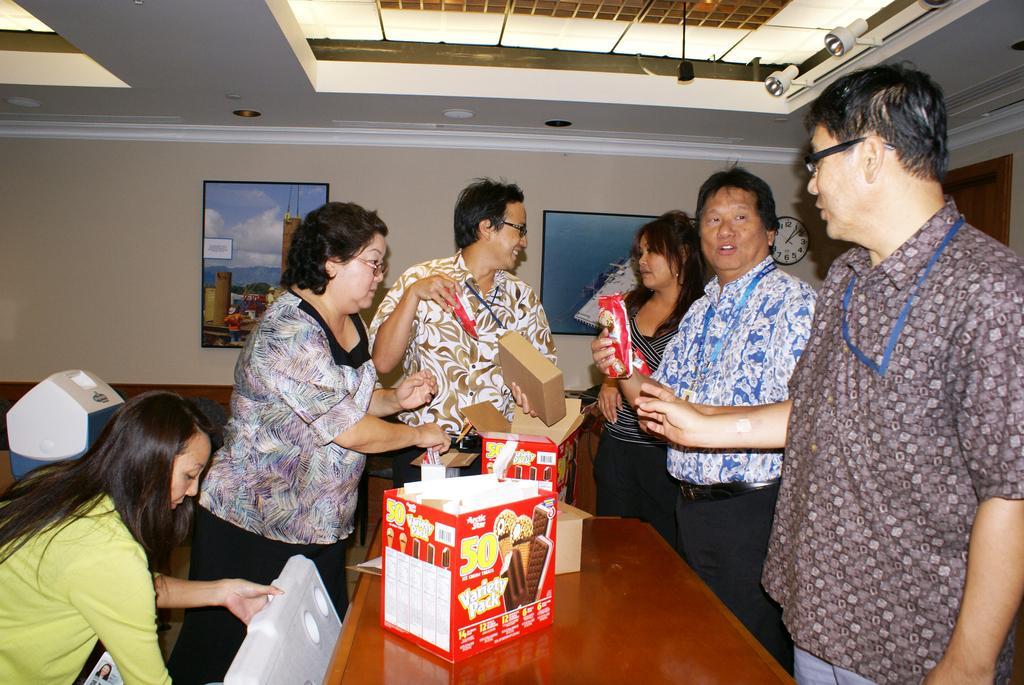How would you summarize this image in a sentence or two? In this image we can see a few people and in front of them there is a table and on the table, we can see some cardboard boxes and other things. In the background, we can see the wall with photo frames and the clock and at the top we can see the ceiling with lights. 